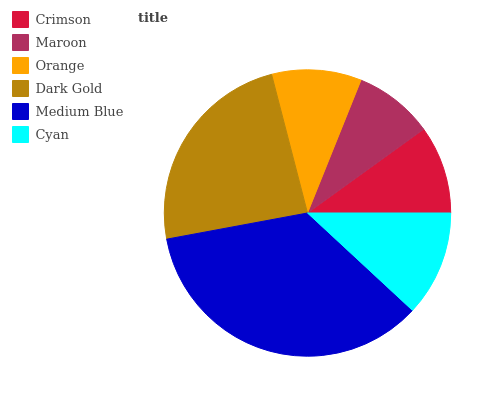Is Maroon the minimum?
Answer yes or no. Yes. Is Medium Blue the maximum?
Answer yes or no. Yes. Is Orange the minimum?
Answer yes or no. No. Is Orange the maximum?
Answer yes or no. No. Is Orange greater than Maroon?
Answer yes or no. Yes. Is Maroon less than Orange?
Answer yes or no. Yes. Is Maroon greater than Orange?
Answer yes or no. No. Is Orange less than Maroon?
Answer yes or no. No. Is Cyan the high median?
Answer yes or no. Yes. Is Orange the low median?
Answer yes or no. Yes. Is Medium Blue the high median?
Answer yes or no. No. Is Medium Blue the low median?
Answer yes or no. No. 